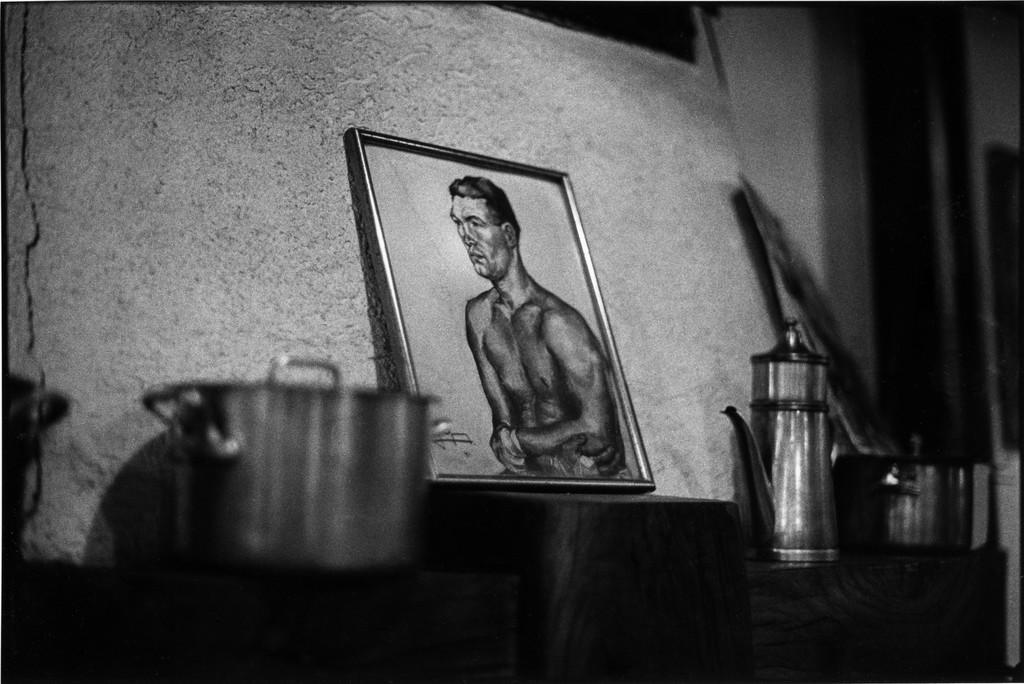What is the color scheme of the image? The image is black and white and white. What objects can be seen in the image? There are utensils in the image. What type of item is displayed in the photo frame? There is a photo frame of a person in the image. What can be seen in the background of the image? There is a wall visible in the image. What type of veil is covering the person in the photo frame? There is no veil present in the image; the photo frame contains a picture of a person without any covering. 